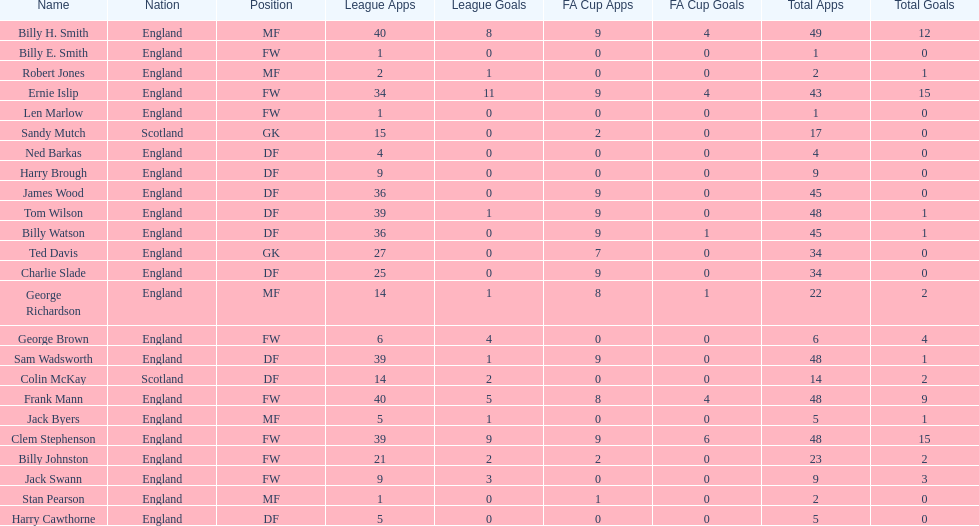How many players are fws? 8. 